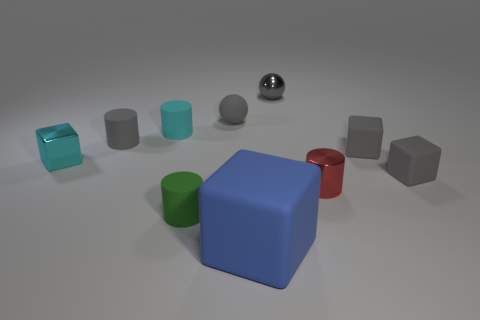What shape is the green thing that is the same material as the large blue thing?
Provide a succinct answer. Cylinder. There is a small shiny object on the left side of the blue matte object; is it the same shape as the big matte thing?
Offer a terse response. Yes. How many purple things are tiny cubes or big rubber things?
Your answer should be very brief. 0. Is the number of small gray metal balls that are behind the shiny ball the same as the number of blocks that are right of the green object?
Keep it short and to the point. No. There is a small rubber cylinder in front of the tiny block to the left of the tiny cylinder on the right side of the green matte thing; what color is it?
Offer a very short reply. Green. Is there anything else that is the same color as the metal sphere?
Ensure brevity in your answer.  Yes. What is the shape of the small metal thing that is the same color as the small matte sphere?
Your answer should be compact. Sphere. There is a matte block that is to the left of the small red thing; how big is it?
Give a very brief answer. Large. What is the shape of the gray metal object that is the same size as the green rubber cylinder?
Make the answer very short. Sphere. Do the cylinder right of the small metal ball and the small cyan object in front of the gray cylinder have the same material?
Your response must be concise. Yes. 